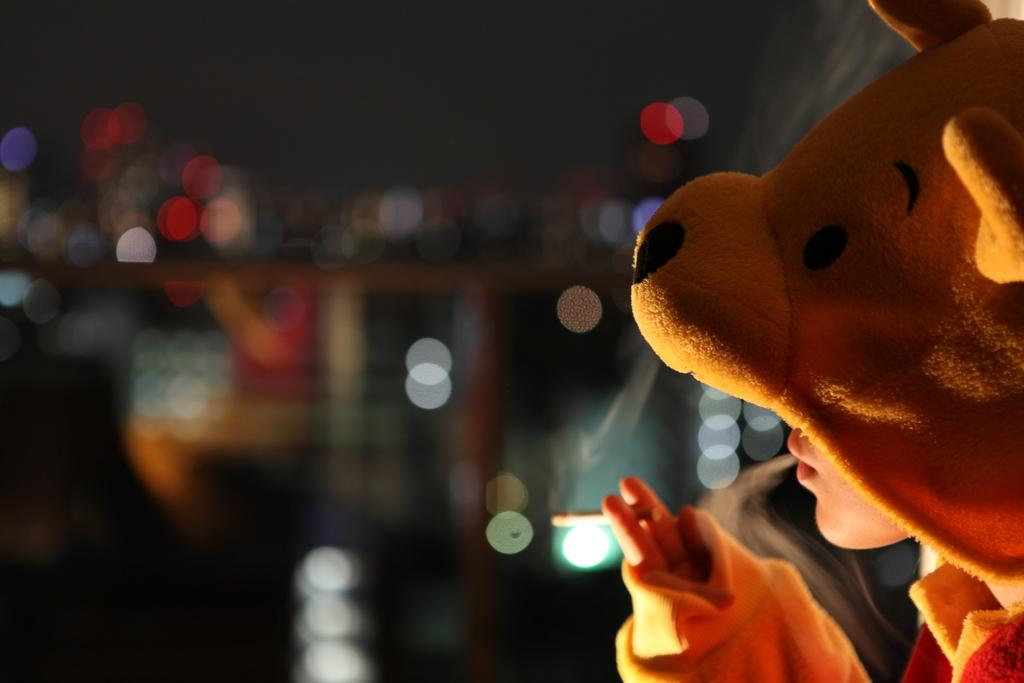What is present in the image? There is a person in the image. What is the person wearing? The person is wearing a teddy bear dress. Where is the person located in the image? The person is on the right side of the image. What is the size of the moon in the image? There is no moon present in the image. How does the root affect the person's appearance in the image? There is no root present in the image, so it cannot affect the person's appearance. 